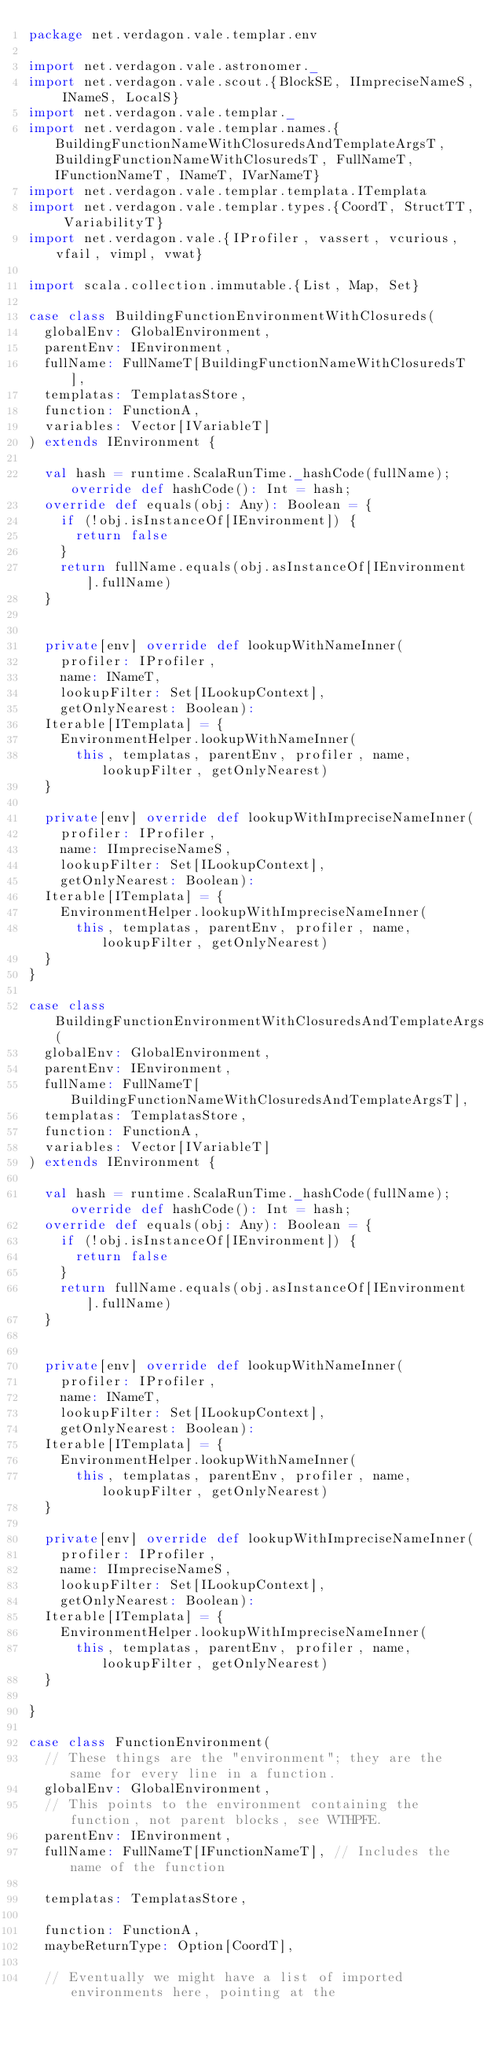Convert code to text. <code><loc_0><loc_0><loc_500><loc_500><_Scala_>package net.verdagon.vale.templar.env

import net.verdagon.vale.astronomer._
import net.verdagon.vale.scout.{BlockSE, IImpreciseNameS, INameS, LocalS}
import net.verdagon.vale.templar._
import net.verdagon.vale.templar.names.{BuildingFunctionNameWithClosuredsAndTemplateArgsT, BuildingFunctionNameWithClosuredsT, FullNameT, IFunctionNameT, INameT, IVarNameT}
import net.verdagon.vale.templar.templata.ITemplata
import net.verdagon.vale.templar.types.{CoordT, StructTT, VariabilityT}
import net.verdagon.vale.{IProfiler, vassert, vcurious, vfail, vimpl, vwat}

import scala.collection.immutable.{List, Map, Set}

case class BuildingFunctionEnvironmentWithClosureds(
  globalEnv: GlobalEnvironment,
  parentEnv: IEnvironment,
  fullName: FullNameT[BuildingFunctionNameWithClosuredsT],
  templatas: TemplatasStore,
  function: FunctionA,
  variables: Vector[IVariableT]
) extends IEnvironment {

  val hash = runtime.ScalaRunTime._hashCode(fullName); override def hashCode(): Int = hash;
  override def equals(obj: Any): Boolean = {
    if (!obj.isInstanceOf[IEnvironment]) {
      return false
    }
    return fullName.equals(obj.asInstanceOf[IEnvironment].fullName)
  }


  private[env] override def lookupWithNameInner(
    profiler: IProfiler,
    name: INameT,
    lookupFilter: Set[ILookupContext],
    getOnlyNearest: Boolean):
  Iterable[ITemplata] = {
    EnvironmentHelper.lookupWithNameInner(
      this, templatas, parentEnv, profiler, name, lookupFilter, getOnlyNearest)
  }

  private[env] override def lookupWithImpreciseNameInner(
    profiler: IProfiler,
    name: IImpreciseNameS,
    lookupFilter: Set[ILookupContext],
    getOnlyNearest: Boolean):
  Iterable[ITemplata] = {
    EnvironmentHelper.lookupWithImpreciseNameInner(
      this, templatas, parentEnv, profiler, name, lookupFilter, getOnlyNearest)
  }
}

case class BuildingFunctionEnvironmentWithClosuredsAndTemplateArgs(
  globalEnv: GlobalEnvironment,
  parentEnv: IEnvironment,
  fullName: FullNameT[BuildingFunctionNameWithClosuredsAndTemplateArgsT],
  templatas: TemplatasStore,
  function: FunctionA,
  variables: Vector[IVariableT]
) extends IEnvironment {

  val hash = runtime.ScalaRunTime._hashCode(fullName); override def hashCode(): Int = hash;
  override def equals(obj: Any): Boolean = {
    if (!obj.isInstanceOf[IEnvironment]) {
      return false
    }
    return fullName.equals(obj.asInstanceOf[IEnvironment].fullName)
  }


  private[env] override def lookupWithNameInner(
    profiler: IProfiler,
    name: INameT,
    lookupFilter: Set[ILookupContext],
    getOnlyNearest: Boolean):
  Iterable[ITemplata] = {
    EnvironmentHelper.lookupWithNameInner(
      this, templatas, parentEnv, profiler, name, lookupFilter, getOnlyNearest)
  }

  private[env] override def lookupWithImpreciseNameInner(
    profiler: IProfiler,
    name: IImpreciseNameS,
    lookupFilter: Set[ILookupContext],
    getOnlyNearest: Boolean):
  Iterable[ITemplata] = {
    EnvironmentHelper.lookupWithImpreciseNameInner(
      this, templatas, parentEnv, profiler, name, lookupFilter, getOnlyNearest)
  }

}

case class FunctionEnvironment(
  // These things are the "environment"; they are the same for every line in a function.
  globalEnv: GlobalEnvironment,
  // This points to the environment containing the function, not parent blocks, see WTHPFE.
  parentEnv: IEnvironment,
  fullName: FullNameT[IFunctionNameT], // Includes the name of the function

  templatas: TemplatasStore,

  function: FunctionA,
  maybeReturnType: Option[CoordT],

  // Eventually we might have a list of imported environments here, pointing at the</code> 